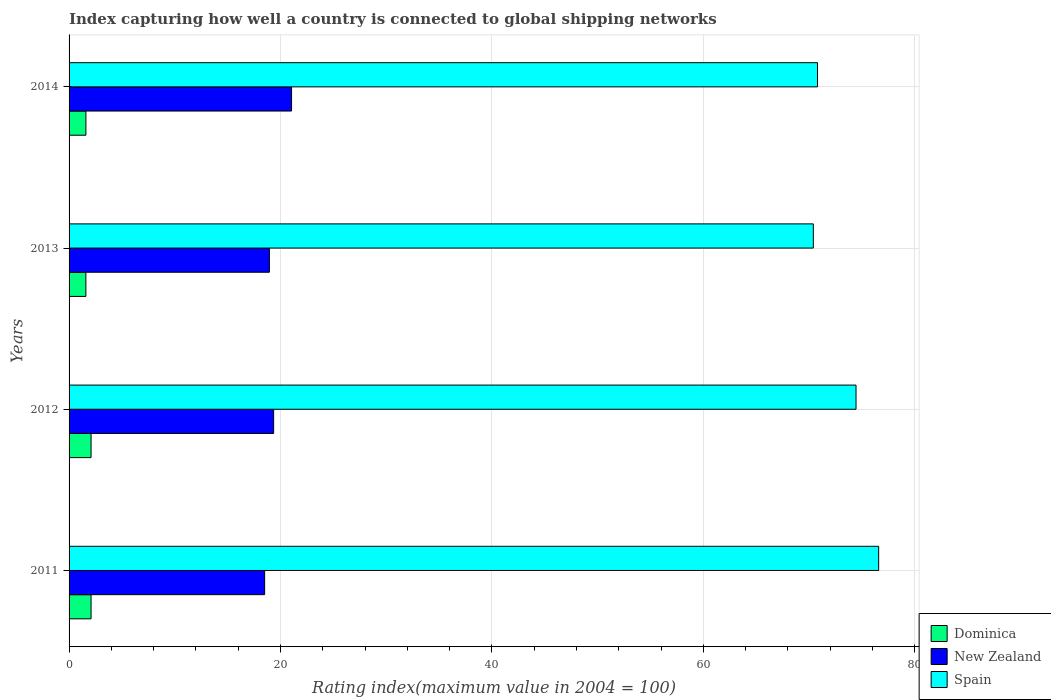Are the number of bars per tick equal to the number of legend labels?
Provide a succinct answer. Yes. Are the number of bars on each tick of the Y-axis equal?
Your answer should be compact. Yes. How many bars are there on the 3rd tick from the top?
Offer a terse response. 3. How many bars are there on the 3rd tick from the bottom?
Provide a succinct answer. 3. What is the label of the 1st group of bars from the top?
Give a very brief answer. 2014. In how many cases, is the number of bars for a given year not equal to the number of legend labels?
Keep it short and to the point. 0. What is the rating index in Dominica in 2014?
Your answer should be compact. 1.59. Across all years, what is the maximum rating index in Dominica?
Give a very brief answer. 2.08. Across all years, what is the minimum rating index in Dominica?
Your answer should be very brief. 1.59. In which year was the rating index in Spain minimum?
Offer a very short reply. 2013. What is the total rating index in Spain in the graph?
Provide a succinct answer. 292.22. What is the difference between the rating index in New Zealand in 2011 and that in 2013?
Provide a succinct answer. -0.45. What is the difference between the rating index in Dominica in 2013 and the rating index in Spain in 2012?
Make the answer very short. -72.85. What is the average rating index in Spain per year?
Provide a succinct answer. 73.05. In the year 2014, what is the difference between the rating index in Spain and rating index in New Zealand?
Offer a terse response. 49.75. In how many years, is the rating index in Spain greater than 40 ?
Your answer should be compact. 4. What is the ratio of the rating index in Dominica in 2013 to that in 2014?
Give a very brief answer. 1. Is the rating index in New Zealand in 2012 less than that in 2014?
Your response must be concise. Yes. Is the difference between the rating index in Spain in 2012 and 2013 greater than the difference between the rating index in New Zealand in 2012 and 2013?
Provide a short and direct response. Yes. What is the difference between the highest and the second highest rating index in Spain?
Your answer should be very brief. 2.14. What is the difference between the highest and the lowest rating index in Dominica?
Ensure brevity in your answer.  0.49. In how many years, is the rating index in New Zealand greater than the average rating index in New Zealand taken over all years?
Make the answer very short. 1. Is the sum of the rating index in New Zealand in 2013 and 2014 greater than the maximum rating index in Dominica across all years?
Provide a short and direct response. Yes. What does the 2nd bar from the top in 2013 represents?
Make the answer very short. New Zealand. What does the 2nd bar from the bottom in 2012 represents?
Your response must be concise. New Zealand. Is it the case that in every year, the sum of the rating index in Dominica and rating index in New Zealand is greater than the rating index in Spain?
Keep it short and to the point. No. How many bars are there?
Your response must be concise. 12. Are all the bars in the graph horizontal?
Ensure brevity in your answer.  Yes. Where does the legend appear in the graph?
Keep it short and to the point. Bottom right. How many legend labels are there?
Your answer should be compact. 3. How are the legend labels stacked?
Make the answer very short. Vertical. What is the title of the graph?
Provide a short and direct response. Index capturing how well a country is connected to global shipping networks. What is the label or title of the X-axis?
Offer a terse response. Rating index(maximum value in 2004 = 100). What is the label or title of the Y-axis?
Offer a terse response. Years. What is the Rating index(maximum value in 2004 = 100) of Dominica in 2011?
Offer a terse response. 2.08. What is the Rating index(maximum value in 2004 = 100) in Spain in 2011?
Make the answer very short. 76.58. What is the Rating index(maximum value in 2004 = 100) in Dominica in 2012?
Keep it short and to the point. 2.08. What is the Rating index(maximum value in 2004 = 100) in New Zealand in 2012?
Provide a short and direct response. 19.35. What is the Rating index(maximum value in 2004 = 100) in Spain in 2012?
Give a very brief answer. 74.44. What is the Rating index(maximum value in 2004 = 100) of Dominica in 2013?
Keep it short and to the point. 1.59. What is the Rating index(maximum value in 2004 = 100) of New Zealand in 2013?
Offer a terse response. 18.95. What is the Rating index(maximum value in 2004 = 100) of Spain in 2013?
Provide a succinct answer. 70.4. What is the Rating index(maximum value in 2004 = 100) of Dominica in 2014?
Your response must be concise. 1.59. What is the Rating index(maximum value in 2004 = 100) in New Zealand in 2014?
Give a very brief answer. 21.04. What is the Rating index(maximum value in 2004 = 100) of Spain in 2014?
Provide a succinct answer. 70.8. Across all years, what is the maximum Rating index(maximum value in 2004 = 100) in Dominica?
Make the answer very short. 2.08. Across all years, what is the maximum Rating index(maximum value in 2004 = 100) of New Zealand?
Ensure brevity in your answer.  21.04. Across all years, what is the maximum Rating index(maximum value in 2004 = 100) of Spain?
Make the answer very short. 76.58. Across all years, what is the minimum Rating index(maximum value in 2004 = 100) of Dominica?
Ensure brevity in your answer.  1.59. Across all years, what is the minimum Rating index(maximum value in 2004 = 100) of Spain?
Offer a terse response. 70.4. What is the total Rating index(maximum value in 2004 = 100) of Dominica in the graph?
Offer a terse response. 7.34. What is the total Rating index(maximum value in 2004 = 100) in New Zealand in the graph?
Keep it short and to the point. 77.84. What is the total Rating index(maximum value in 2004 = 100) of Spain in the graph?
Provide a short and direct response. 292.22. What is the difference between the Rating index(maximum value in 2004 = 100) in Dominica in 2011 and that in 2012?
Ensure brevity in your answer.  0. What is the difference between the Rating index(maximum value in 2004 = 100) in New Zealand in 2011 and that in 2012?
Offer a very short reply. -0.85. What is the difference between the Rating index(maximum value in 2004 = 100) of Spain in 2011 and that in 2012?
Provide a succinct answer. 2.14. What is the difference between the Rating index(maximum value in 2004 = 100) in Dominica in 2011 and that in 2013?
Provide a succinct answer. 0.49. What is the difference between the Rating index(maximum value in 2004 = 100) of New Zealand in 2011 and that in 2013?
Ensure brevity in your answer.  -0.45. What is the difference between the Rating index(maximum value in 2004 = 100) in Spain in 2011 and that in 2013?
Offer a very short reply. 6.18. What is the difference between the Rating index(maximum value in 2004 = 100) in Dominica in 2011 and that in 2014?
Offer a terse response. 0.49. What is the difference between the Rating index(maximum value in 2004 = 100) of New Zealand in 2011 and that in 2014?
Your response must be concise. -2.54. What is the difference between the Rating index(maximum value in 2004 = 100) of Spain in 2011 and that in 2014?
Keep it short and to the point. 5.78. What is the difference between the Rating index(maximum value in 2004 = 100) in Dominica in 2012 and that in 2013?
Your response must be concise. 0.49. What is the difference between the Rating index(maximum value in 2004 = 100) in New Zealand in 2012 and that in 2013?
Offer a terse response. 0.4. What is the difference between the Rating index(maximum value in 2004 = 100) of Spain in 2012 and that in 2013?
Your answer should be very brief. 4.04. What is the difference between the Rating index(maximum value in 2004 = 100) in Dominica in 2012 and that in 2014?
Provide a short and direct response. 0.49. What is the difference between the Rating index(maximum value in 2004 = 100) in New Zealand in 2012 and that in 2014?
Offer a terse response. -1.7. What is the difference between the Rating index(maximum value in 2004 = 100) in Spain in 2012 and that in 2014?
Offer a terse response. 3.64. What is the difference between the Rating index(maximum value in 2004 = 100) of Dominica in 2013 and that in 2014?
Your response must be concise. -0. What is the difference between the Rating index(maximum value in 2004 = 100) of New Zealand in 2013 and that in 2014?
Ensure brevity in your answer.  -2.1. What is the difference between the Rating index(maximum value in 2004 = 100) in Spain in 2013 and that in 2014?
Make the answer very short. -0.4. What is the difference between the Rating index(maximum value in 2004 = 100) of Dominica in 2011 and the Rating index(maximum value in 2004 = 100) of New Zealand in 2012?
Your response must be concise. -17.27. What is the difference between the Rating index(maximum value in 2004 = 100) in Dominica in 2011 and the Rating index(maximum value in 2004 = 100) in Spain in 2012?
Make the answer very short. -72.36. What is the difference between the Rating index(maximum value in 2004 = 100) of New Zealand in 2011 and the Rating index(maximum value in 2004 = 100) of Spain in 2012?
Make the answer very short. -55.94. What is the difference between the Rating index(maximum value in 2004 = 100) of Dominica in 2011 and the Rating index(maximum value in 2004 = 100) of New Zealand in 2013?
Give a very brief answer. -16.87. What is the difference between the Rating index(maximum value in 2004 = 100) in Dominica in 2011 and the Rating index(maximum value in 2004 = 100) in Spain in 2013?
Provide a short and direct response. -68.32. What is the difference between the Rating index(maximum value in 2004 = 100) in New Zealand in 2011 and the Rating index(maximum value in 2004 = 100) in Spain in 2013?
Your answer should be compact. -51.9. What is the difference between the Rating index(maximum value in 2004 = 100) of Dominica in 2011 and the Rating index(maximum value in 2004 = 100) of New Zealand in 2014?
Keep it short and to the point. -18.96. What is the difference between the Rating index(maximum value in 2004 = 100) in Dominica in 2011 and the Rating index(maximum value in 2004 = 100) in Spain in 2014?
Offer a terse response. -68.72. What is the difference between the Rating index(maximum value in 2004 = 100) of New Zealand in 2011 and the Rating index(maximum value in 2004 = 100) of Spain in 2014?
Your answer should be compact. -52.3. What is the difference between the Rating index(maximum value in 2004 = 100) of Dominica in 2012 and the Rating index(maximum value in 2004 = 100) of New Zealand in 2013?
Ensure brevity in your answer.  -16.87. What is the difference between the Rating index(maximum value in 2004 = 100) in Dominica in 2012 and the Rating index(maximum value in 2004 = 100) in Spain in 2013?
Provide a succinct answer. -68.32. What is the difference between the Rating index(maximum value in 2004 = 100) in New Zealand in 2012 and the Rating index(maximum value in 2004 = 100) in Spain in 2013?
Offer a terse response. -51.05. What is the difference between the Rating index(maximum value in 2004 = 100) in Dominica in 2012 and the Rating index(maximum value in 2004 = 100) in New Zealand in 2014?
Keep it short and to the point. -18.96. What is the difference between the Rating index(maximum value in 2004 = 100) of Dominica in 2012 and the Rating index(maximum value in 2004 = 100) of Spain in 2014?
Make the answer very short. -68.72. What is the difference between the Rating index(maximum value in 2004 = 100) of New Zealand in 2012 and the Rating index(maximum value in 2004 = 100) of Spain in 2014?
Your answer should be compact. -51.45. What is the difference between the Rating index(maximum value in 2004 = 100) of Dominica in 2013 and the Rating index(maximum value in 2004 = 100) of New Zealand in 2014?
Give a very brief answer. -19.45. What is the difference between the Rating index(maximum value in 2004 = 100) in Dominica in 2013 and the Rating index(maximum value in 2004 = 100) in Spain in 2014?
Provide a short and direct response. -69.21. What is the difference between the Rating index(maximum value in 2004 = 100) in New Zealand in 2013 and the Rating index(maximum value in 2004 = 100) in Spain in 2014?
Provide a succinct answer. -51.85. What is the average Rating index(maximum value in 2004 = 100) of Dominica per year?
Make the answer very short. 1.84. What is the average Rating index(maximum value in 2004 = 100) in New Zealand per year?
Offer a very short reply. 19.46. What is the average Rating index(maximum value in 2004 = 100) in Spain per year?
Your response must be concise. 73.05. In the year 2011, what is the difference between the Rating index(maximum value in 2004 = 100) in Dominica and Rating index(maximum value in 2004 = 100) in New Zealand?
Offer a terse response. -16.42. In the year 2011, what is the difference between the Rating index(maximum value in 2004 = 100) of Dominica and Rating index(maximum value in 2004 = 100) of Spain?
Give a very brief answer. -74.5. In the year 2011, what is the difference between the Rating index(maximum value in 2004 = 100) of New Zealand and Rating index(maximum value in 2004 = 100) of Spain?
Ensure brevity in your answer.  -58.08. In the year 2012, what is the difference between the Rating index(maximum value in 2004 = 100) in Dominica and Rating index(maximum value in 2004 = 100) in New Zealand?
Give a very brief answer. -17.27. In the year 2012, what is the difference between the Rating index(maximum value in 2004 = 100) in Dominica and Rating index(maximum value in 2004 = 100) in Spain?
Give a very brief answer. -72.36. In the year 2012, what is the difference between the Rating index(maximum value in 2004 = 100) in New Zealand and Rating index(maximum value in 2004 = 100) in Spain?
Provide a short and direct response. -55.09. In the year 2013, what is the difference between the Rating index(maximum value in 2004 = 100) in Dominica and Rating index(maximum value in 2004 = 100) in New Zealand?
Offer a very short reply. -17.36. In the year 2013, what is the difference between the Rating index(maximum value in 2004 = 100) in Dominica and Rating index(maximum value in 2004 = 100) in Spain?
Keep it short and to the point. -68.81. In the year 2013, what is the difference between the Rating index(maximum value in 2004 = 100) of New Zealand and Rating index(maximum value in 2004 = 100) of Spain?
Your answer should be compact. -51.45. In the year 2014, what is the difference between the Rating index(maximum value in 2004 = 100) in Dominica and Rating index(maximum value in 2004 = 100) in New Zealand?
Ensure brevity in your answer.  -19.45. In the year 2014, what is the difference between the Rating index(maximum value in 2004 = 100) in Dominica and Rating index(maximum value in 2004 = 100) in Spain?
Your response must be concise. -69.2. In the year 2014, what is the difference between the Rating index(maximum value in 2004 = 100) of New Zealand and Rating index(maximum value in 2004 = 100) of Spain?
Your answer should be very brief. -49.75. What is the ratio of the Rating index(maximum value in 2004 = 100) of Dominica in 2011 to that in 2012?
Offer a terse response. 1. What is the ratio of the Rating index(maximum value in 2004 = 100) in New Zealand in 2011 to that in 2012?
Offer a terse response. 0.96. What is the ratio of the Rating index(maximum value in 2004 = 100) of Spain in 2011 to that in 2012?
Ensure brevity in your answer.  1.03. What is the ratio of the Rating index(maximum value in 2004 = 100) in Dominica in 2011 to that in 2013?
Give a very brief answer. 1.31. What is the ratio of the Rating index(maximum value in 2004 = 100) in New Zealand in 2011 to that in 2013?
Your answer should be compact. 0.98. What is the ratio of the Rating index(maximum value in 2004 = 100) of Spain in 2011 to that in 2013?
Make the answer very short. 1.09. What is the ratio of the Rating index(maximum value in 2004 = 100) of Dominica in 2011 to that in 2014?
Ensure brevity in your answer.  1.31. What is the ratio of the Rating index(maximum value in 2004 = 100) of New Zealand in 2011 to that in 2014?
Ensure brevity in your answer.  0.88. What is the ratio of the Rating index(maximum value in 2004 = 100) of Spain in 2011 to that in 2014?
Make the answer very short. 1.08. What is the ratio of the Rating index(maximum value in 2004 = 100) of Dominica in 2012 to that in 2013?
Ensure brevity in your answer.  1.31. What is the ratio of the Rating index(maximum value in 2004 = 100) in New Zealand in 2012 to that in 2013?
Give a very brief answer. 1.02. What is the ratio of the Rating index(maximum value in 2004 = 100) in Spain in 2012 to that in 2013?
Your answer should be very brief. 1.06. What is the ratio of the Rating index(maximum value in 2004 = 100) of Dominica in 2012 to that in 2014?
Provide a short and direct response. 1.31. What is the ratio of the Rating index(maximum value in 2004 = 100) in New Zealand in 2012 to that in 2014?
Your response must be concise. 0.92. What is the ratio of the Rating index(maximum value in 2004 = 100) in Spain in 2012 to that in 2014?
Ensure brevity in your answer.  1.05. What is the ratio of the Rating index(maximum value in 2004 = 100) in New Zealand in 2013 to that in 2014?
Your answer should be very brief. 0.9. What is the difference between the highest and the second highest Rating index(maximum value in 2004 = 100) of Dominica?
Your answer should be very brief. 0. What is the difference between the highest and the second highest Rating index(maximum value in 2004 = 100) of New Zealand?
Make the answer very short. 1.7. What is the difference between the highest and the second highest Rating index(maximum value in 2004 = 100) of Spain?
Offer a very short reply. 2.14. What is the difference between the highest and the lowest Rating index(maximum value in 2004 = 100) of Dominica?
Your response must be concise. 0.49. What is the difference between the highest and the lowest Rating index(maximum value in 2004 = 100) in New Zealand?
Offer a very short reply. 2.54. What is the difference between the highest and the lowest Rating index(maximum value in 2004 = 100) in Spain?
Offer a very short reply. 6.18. 